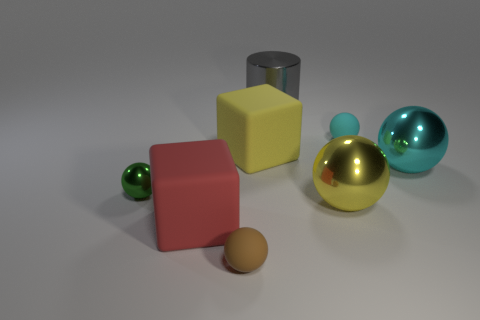Could this be an image from a computer graphics rendering? Yes, this could very well be a computer graphics rendering. The perfectly smooth surfaces and the uniform lighting suggest that this may not be a photograph of real objects, but rather a digital construction designed to mimic reality. 